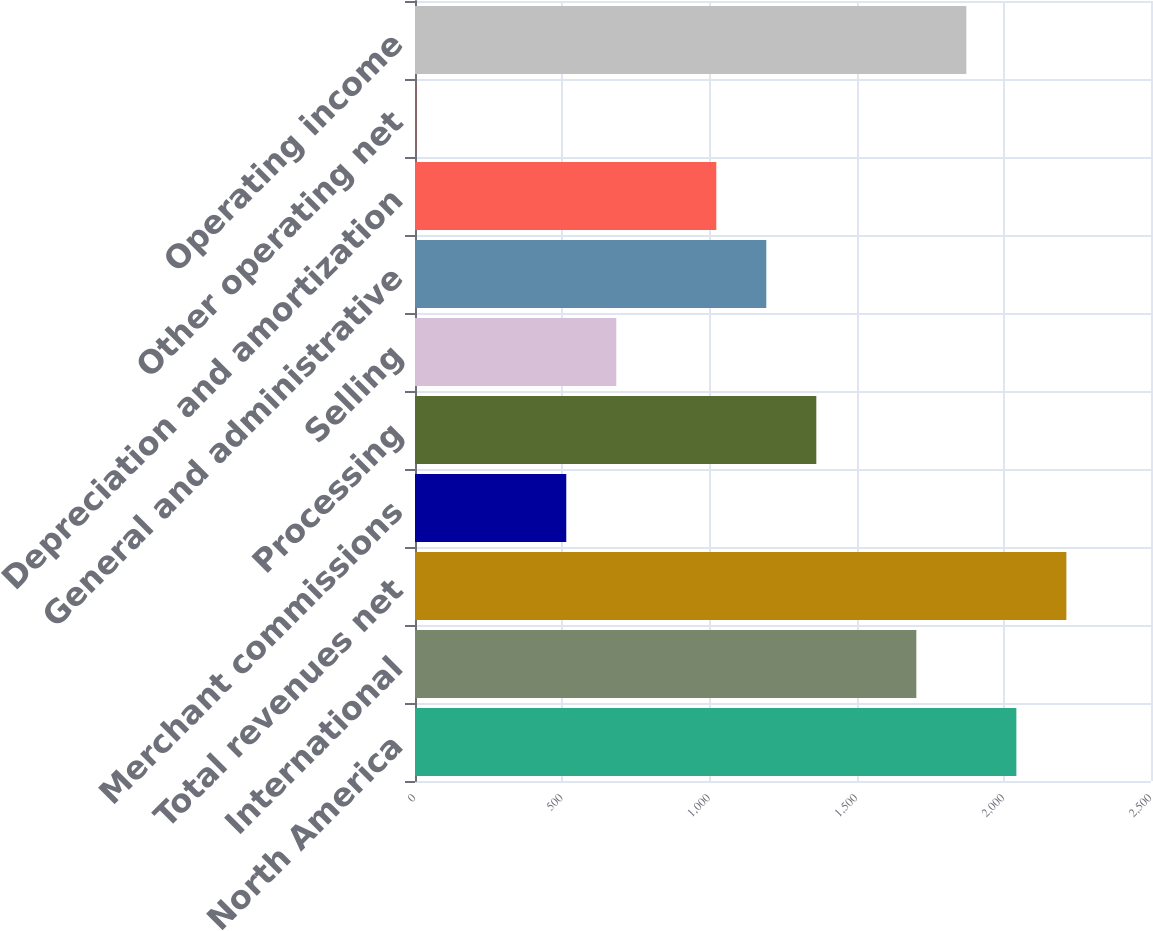Convert chart to OTSL. <chart><loc_0><loc_0><loc_500><loc_500><bar_chart><fcel>North America<fcel>International<fcel>Total revenues net<fcel>Merchant commissions<fcel>Processing<fcel>Selling<fcel>General and administrative<fcel>Depreciation and amortization<fcel>Other operating net<fcel>Operating income<nl><fcel>2042.64<fcel>1702.9<fcel>2212.51<fcel>513.81<fcel>1363.16<fcel>683.68<fcel>1193.29<fcel>1023.42<fcel>4.2<fcel>1872.77<nl></chart> 